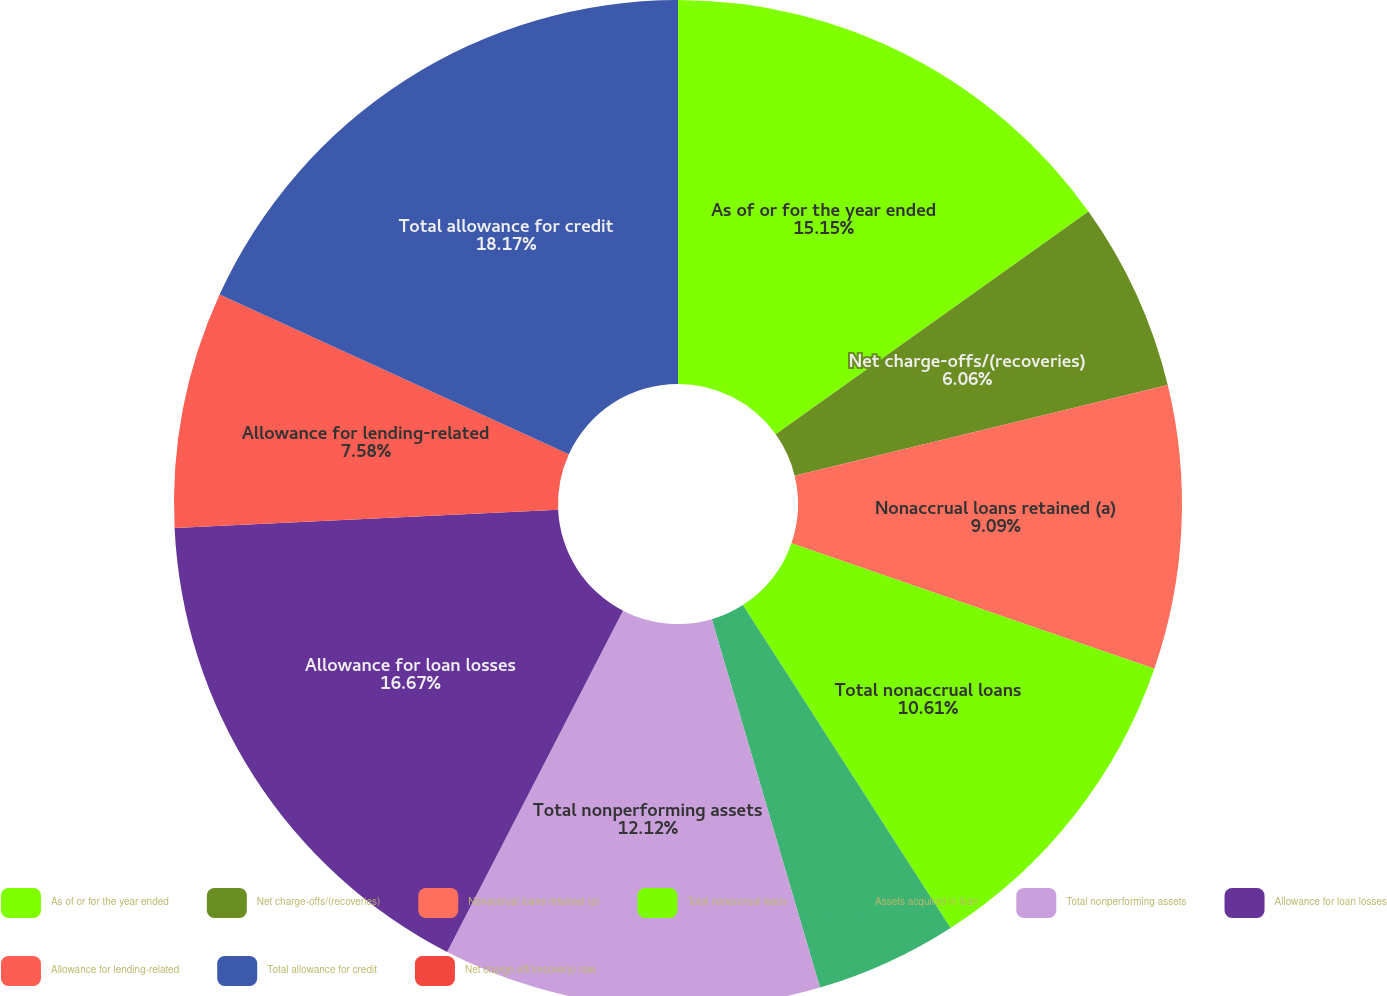Convert chart. <chart><loc_0><loc_0><loc_500><loc_500><pie_chart><fcel>As of or for the year ended<fcel>Net charge-offs/(recoveries)<fcel>Nonaccrual loans retained (a)<fcel>Total nonaccrual loans<fcel>Assets acquired in loan<fcel>Total nonperforming assets<fcel>Allowance for loan losses<fcel>Allowance for lending-related<fcel>Total allowance for credit<fcel>Net charge-off/(recovery) rate<nl><fcel>15.15%<fcel>6.06%<fcel>9.09%<fcel>10.61%<fcel>4.55%<fcel>12.12%<fcel>16.67%<fcel>7.58%<fcel>18.18%<fcel>0.0%<nl></chart> 